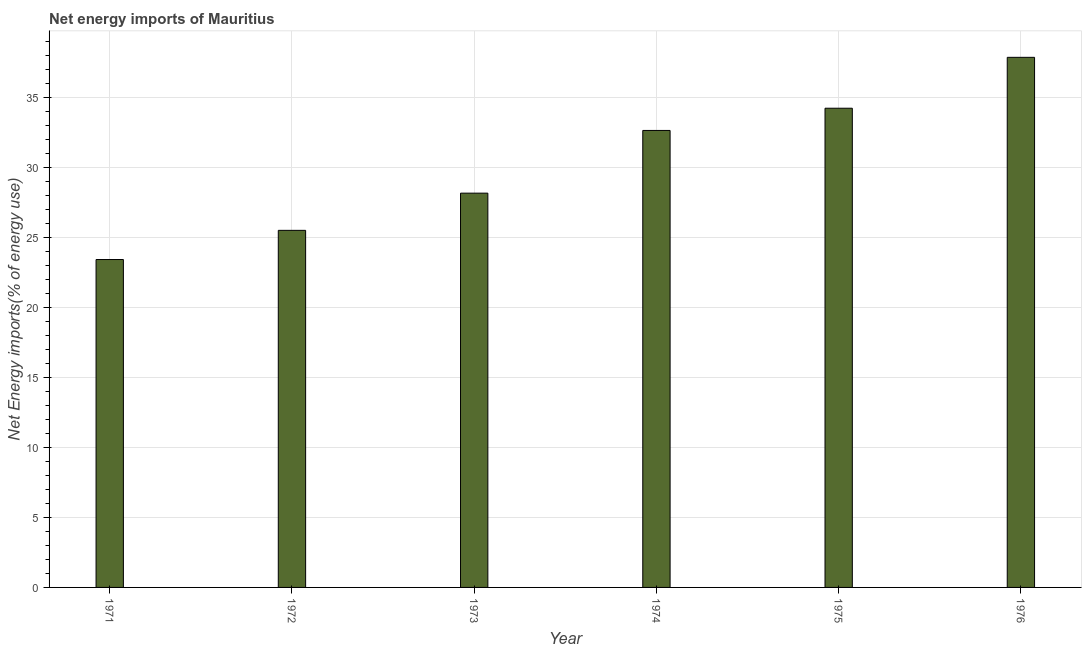Does the graph contain any zero values?
Provide a short and direct response. No. Does the graph contain grids?
Keep it short and to the point. Yes. What is the title of the graph?
Provide a succinct answer. Net energy imports of Mauritius. What is the label or title of the X-axis?
Your answer should be compact. Year. What is the label or title of the Y-axis?
Make the answer very short. Net Energy imports(% of energy use). What is the energy imports in 1972?
Provide a succinct answer. 25.49. Across all years, what is the maximum energy imports?
Provide a short and direct response. 37.84. Across all years, what is the minimum energy imports?
Make the answer very short. 23.4. In which year was the energy imports maximum?
Make the answer very short. 1976. In which year was the energy imports minimum?
Make the answer very short. 1971. What is the sum of the energy imports?
Offer a terse response. 181.69. What is the difference between the energy imports in 1971 and 1972?
Your response must be concise. -2.08. What is the average energy imports per year?
Your answer should be very brief. 30.28. What is the median energy imports?
Provide a succinct answer. 30.38. In how many years, is the energy imports greater than 17 %?
Your answer should be very brief. 6. Do a majority of the years between 1976 and 1974 (inclusive) have energy imports greater than 3 %?
Make the answer very short. Yes. What is the ratio of the energy imports in 1975 to that in 1976?
Give a very brief answer. 0.9. Is the difference between the energy imports in 1973 and 1974 greater than the difference between any two years?
Offer a very short reply. No. What is the difference between the highest and the second highest energy imports?
Keep it short and to the point. 3.63. Is the sum of the energy imports in 1972 and 1976 greater than the maximum energy imports across all years?
Provide a succinct answer. Yes. What is the difference between the highest and the lowest energy imports?
Offer a very short reply. 14.43. Are all the bars in the graph horizontal?
Ensure brevity in your answer.  No. How many years are there in the graph?
Make the answer very short. 6. What is the difference between two consecutive major ticks on the Y-axis?
Your answer should be very brief. 5. Are the values on the major ticks of Y-axis written in scientific E-notation?
Keep it short and to the point. No. What is the Net Energy imports(% of energy use) of 1971?
Provide a short and direct response. 23.4. What is the Net Energy imports(% of energy use) in 1972?
Offer a terse response. 25.49. What is the Net Energy imports(% of energy use) of 1973?
Provide a succinct answer. 28.14. What is the Net Energy imports(% of energy use) in 1974?
Your response must be concise. 32.62. What is the Net Energy imports(% of energy use) of 1975?
Your response must be concise. 34.2. What is the Net Energy imports(% of energy use) of 1976?
Provide a succinct answer. 37.84. What is the difference between the Net Energy imports(% of energy use) in 1971 and 1972?
Keep it short and to the point. -2.08. What is the difference between the Net Energy imports(% of energy use) in 1971 and 1973?
Offer a very short reply. -4.74. What is the difference between the Net Energy imports(% of energy use) in 1971 and 1974?
Give a very brief answer. -9.21. What is the difference between the Net Energy imports(% of energy use) in 1971 and 1975?
Your response must be concise. -10.8. What is the difference between the Net Energy imports(% of energy use) in 1971 and 1976?
Offer a terse response. -14.43. What is the difference between the Net Energy imports(% of energy use) in 1972 and 1973?
Provide a short and direct response. -2.66. What is the difference between the Net Energy imports(% of energy use) in 1972 and 1974?
Keep it short and to the point. -7.13. What is the difference between the Net Energy imports(% of energy use) in 1972 and 1975?
Offer a terse response. -8.72. What is the difference between the Net Energy imports(% of energy use) in 1972 and 1976?
Offer a terse response. -12.35. What is the difference between the Net Energy imports(% of energy use) in 1973 and 1974?
Make the answer very short. -4.48. What is the difference between the Net Energy imports(% of energy use) in 1973 and 1975?
Offer a very short reply. -6.06. What is the difference between the Net Energy imports(% of energy use) in 1973 and 1976?
Keep it short and to the point. -9.69. What is the difference between the Net Energy imports(% of energy use) in 1974 and 1975?
Ensure brevity in your answer.  -1.59. What is the difference between the Net Energy imports(% of energy use) in 1974 and 1976?
Ensure brevity in your answer.  -5.22. What is the difference between the Net Energy imports(% of energy use) in 1975 and 1976?
Your response must be concise. -3.63. What is the ratio of the Net Energy imports(% of energy use) in 1971 to that in 1972?
Offer a terse response. 0.92. What is the ratio of the Net Energy imports(% of energy use) in 1971 to that in 1973?
Your answer should be compact. 0.83. What is the ratio of the Net Energy imports(% of energy use) in 1971 to that in 1974?
Provide a succinct answer. 0.72. What is the ratio of the Net Energy imports(% of energy use) in 1971 to that in 1975?
Give a very brief answer. 0.68. What is the ratio of the Net Energy imports(% of energy use) in 1971 to that in 1976?
Offer a terse response. 0.62. What is the ratio of the Net Energy imports(% of energy use) in 1972 to that in 1973?
Provide a succinct answer. 0.91. What is the ratio of the Net Energy imports(% of energy use) in 1972 to that in 1974?
Your answer should be very brief. 0.78. What is the ratio of the Net Energy imports(% of energy use) in 1972 to that in 1975?
Keep it short and to the point. 0.74. What is the ratio of the Net Energy imports(% of energy use) in 1972 to that in 1976?
Give a very brief answer. 0.67. What is the ratio of the Net Energy imports(% of energy use) in 1973 to that in 1974?
Your answer should be very brief. 0.86. What is the ratio of the Net Energy imports(% of energy use) in 1973 to that in 1975?
Your answer should be compact. 0.82. What is the ratio of the Net Energy imports(% of energy use) in 1973 to that in 1976?
Provide a short and direct response. 0.74. What is the ratio of the Net Energy imports(% of energy use) in 1974 to that in 1975?
Ensure brevity in your answer.  0.95. What is the ratio of the Net Energy imports(% of energy use) in 1974 to that in 1976?
Your answer should be very brief. 0.86. What is the ratio of the Net Energy imports(% of energy use) in 1975 to that in 1976?
Give a very brief answer. 0.9. 